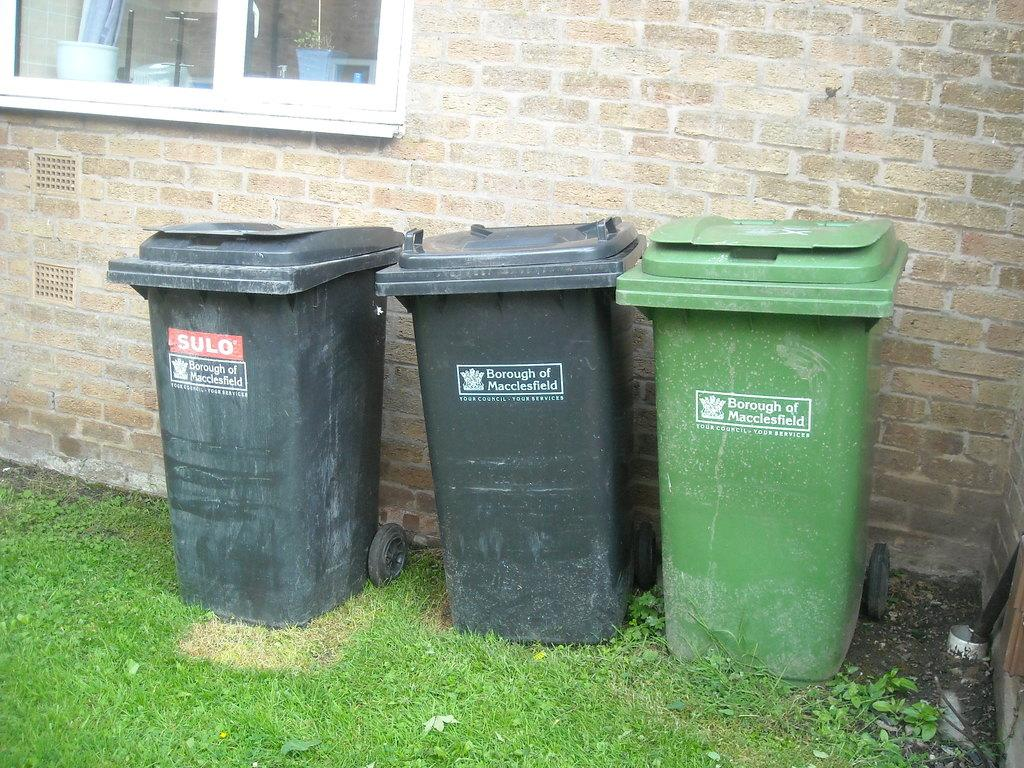<image>
Render a clear and concise summary of the photo. The Sulo brand name is on a trash bin next to other bins. 